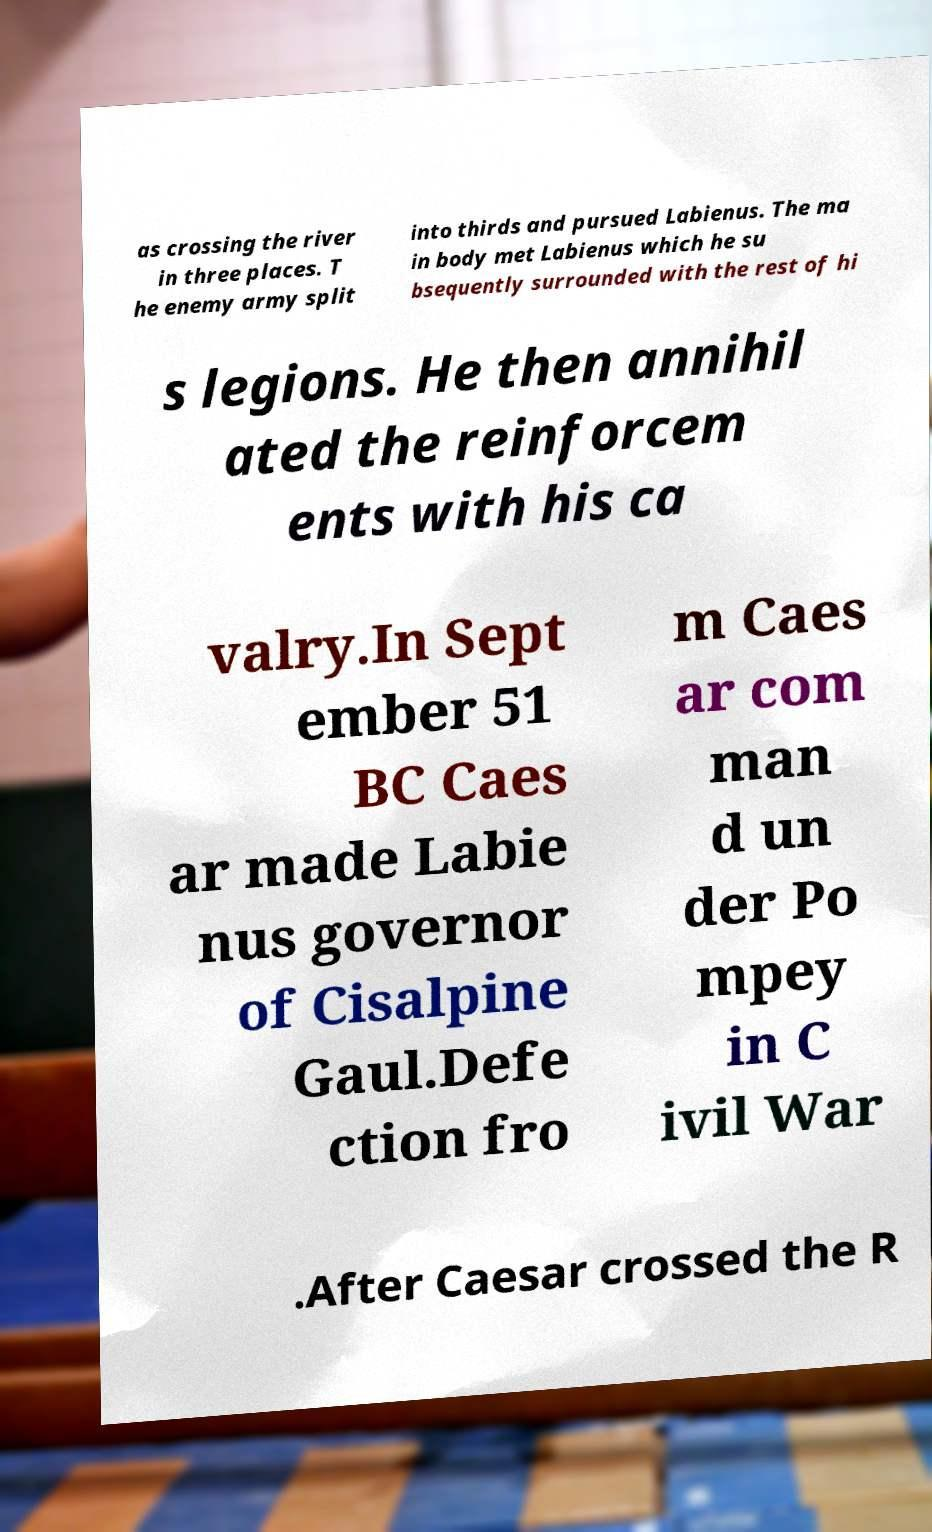Could you extract and type out the text from this image? as crossing the river in three places. T he enemy army split into thirds and pursued Labienus. The ma in body met Labienus which he su bsequently surrounded with the rest of hi s legions. He then annihil ated the reinforcem ents with his ca valry.In Sept ember 51 BC Caes ar made Labie nus governor of Cisalpine Gaul.Defe ction fro m Caes ar com man d un der Po mpey in C ivil War .After Caesar crossed the R 